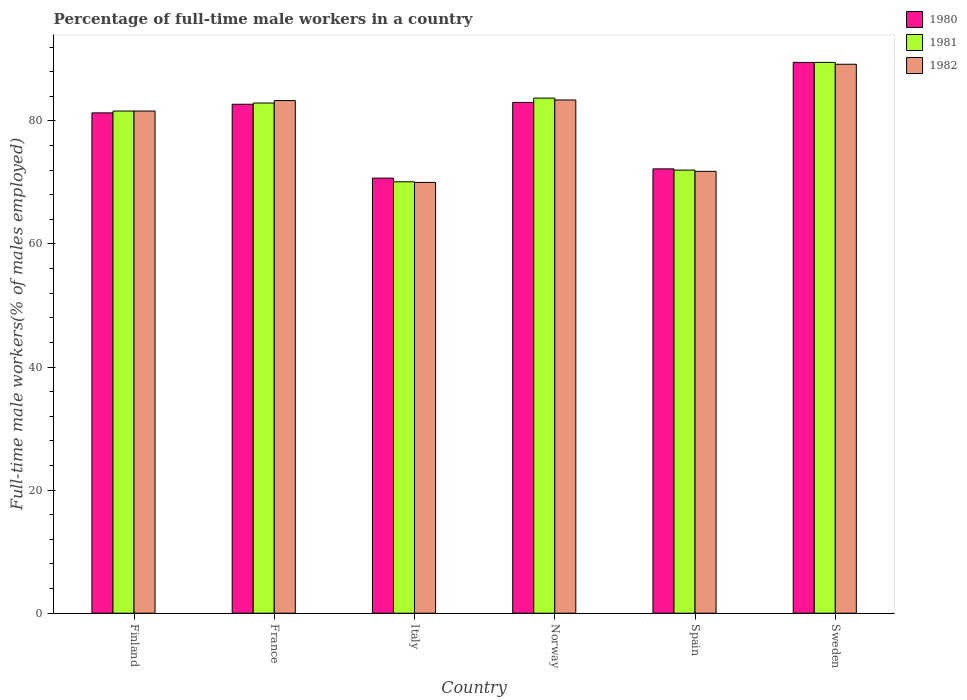How many different coloured bars are there?
Provide a short and direct response. 3. How many groups of bars are there?
Your answer should be compact. 6. Are the number of bars per tick equal to the number of legend labels?
Your response must be concise. Yes. How many bars are there on the 1st tick from the left?
Keep it short and to the point. 3. What is the label of the 3rd group of bars from the left?
Your response must be concise. Italy. What is the percentage of full-time male workers in 1982 in Sweden?
Give a very brief answer. 89.2. Across all countries, what is the maximum percentage of full-time male workers in 1980?
Provide a succinct answer. 89.5. Across all countries, what is the minimum percentage of full-time male workers in 1982?
Keep it short and to the point. 70. In which country was the percentage of full-time male workers in 1982 maximum?
Your response must be concise. Sweden. In which country was the percentage of full-time male workers in 1980 minimum?
Offer a terse response. Italy. What is the total percentage of full-time male workers in 1982 in the graph?
Your response must be concise. 479.3. What is the difference between the percentage of full-time male workers in 1982 in Norway and that in Sweden?
Offer a very short reply. -5.8. What is the difference between the percentage of full-time male workers in 1982 in Spain and the percentage of full-time male workers in 1981 in Norway?
Ensure brevity in your answer.  -11.9. What is the average percentage of full-time male workers in 1982 per country?
Ensure brevity in your answer.  79.88. What is the difference between the percentage of full-time male workers of/in 1981 and percentage of full-time male workers of/in 1982 in Sweden?
Your answer should be compact. 0.3. What is the ratio of the percentage of full-time male workers in 1981 in France to that in Italy?
Give a very brief answer. 1.18. What is the difference between the highest and the second highest percentage of full-time male workers in 1982?
Keep it short and to the point. 5.9. What is the difference between the highest and the lowest percentage of full-time male workers in 1980?
Provide a succinct answer. 18.8. In how many countries, is the percentage of full-time male workers in 1981 greater than the average percentage of full-time male workers in 1981 taken over all countries?
Provide a short and direct response. 4. Is the sum of the percentage of full-time male workers in 1980 in Italy and Spain greater than the maximum percentage of full-time male workers in 1982 across all countries?
Ensure brevity in your answer.  Yes. What does the 3rd bar from the left in France represents?
Give a very brief answer. 1982. What does the 3rd bar from the right in Italy represents?
Provide a succinct answer. 1980. Are all the bars in the graph horizontal?
Give a very brief answer. No. How many countries are there in the graph?
Your answer should be very brief. 6. What is the difference between two consecutive major ticks on the Y-axis?
Ensure brevity in your answer.  20. Where does the legend appear in the graph?
Provide a short and direct response. Top right. How many legend labels are there?
Provide a short and direct response. 3. How are the legend labels stacked?
Your response must be concise. Vertical. What is the title of the graph?
Your answer should be compact. Percentage of full-time male workers in a country. Does "1962" appear as one of the legend labels in the graph?
Offer a very short reply. No. What is the label or title of the Y-axis?
Give a very brief answer. Full-time male workers(% of males employed). What is the Full-time male workers(% of males employed) in 1980 in Finland?
Offer a terse response. 81.3. What is the Full-time male workers(% of males employed) of 1981 in Finland?
Offer a very short reply. 81.6. What is the Full-time male workers(% of males employed) of 1982 in Finland?
Ensure brevity in your answer.  81.6. What is the Full-time male workers(% of males employed) in 1980 in France?
Provide a succinct answer. 82.7. What is the Full-time male workers(% of males employed) of 1981 in France?
Ensure brevity in your answer.  82.9. What is the Full-time male workers(% of males employed) in 1982 in France?
Offer a terse response. 83.3. What is the Full-time male workers(% of males employed) in 1980 in Italy?
Make the answer very short. 70.7. What is the Full-time male workers(% of males employed) in 1981 in Italy?
Ensure brevity in your answer.  70.1. What is the Full-time male workers(% of males employed) of 1982 in Italy?
Your answer should be compact. 70. What is the Full-time male workers(% of males employed) in 1981 in Norway?
Your answer should be compact. 83.7. What is the Full-time male workers(% of males employed) of 1982 in Norway?
Your answer should be very brief. 83.4. What is the Full-time male workers(% of males employed) in 1980 in Spain?
Your answer should be compact. 72.2. What is the Full-time male workers(% of males employed) in 1981 in Spain?
Keep it short and to the point. 72. What is the Full-time male workers(% of males employed) in 1982 in Spain?
Offer a very short reply. 71.8. What is the Full-time male workers(% of males employed) of 1980 in Sweden?
Offer a very short reply. 89.5. What is the Full-time male workers(% of males employed) of 1981 in Sweden?
Keep it short and to the point. 89.5. What is the Full-time male workers(% of males employed) in 1982 in Sweden?
Provide a succinct answer. 89.2. Across all countries, what is the maximum Full-time male workers(% of males employed) of 1980?
Provide a short and direct response. 89.5. Across all countries, what is the maximum Full-time male workers(% of males employed) of 1981?
Give a very brief answer. 89.5. Across all countries, what is the maximum Full-time male workers(% of males employed) in 1982?
Keep it short and to the point. 89.2. Across all countries, what is the minimum Full-time male workers(% of males employed) in 1980?
Ensure brevity in your answer.  70.7. Across all countries, what is the minimum Full-time male workers(% of males employed) of 1981?
Give a very brief answer. 70.1. What is the total Full-time male workers(% of males employed) in 1980 in the graph?
Your answer should be very brief. 479.4. What is the total Full-time male workers(% of males employed) of 1981 in the graph?
Provide a short and direct response. 479.8. What is the total Full-time male workers(% of males employed) of 1982 in the graph?
Provide a succinct answer. 479.3. What is the difference between the Full-time male workers(% of males employed) of 1981 in Finland and that in Italy?
Provide a short and direct response. 11.5. What is the difference between the Full-time male workers(% of males employed) in 1982 in Finland and that in Italy?
Provide a succinct answer. 11.6. What is the difference between the Full-time male workers(% of males employed) of 1980 in Finland and that in Norway?
Give a very brief answer. -1.7. What is the difference between the Full-time male workers(% of males employed) in 1982 in Finland and that in Norway?
Provide a succinct answer. -1.8. What is the difference between the Full-time male workers(% of males employed) in 1980 in Finland and that in Spain?
Offer a terse response. 9.1. What is the difference between the Full-time male workers(% of males employed) of 1982 in Finland and that in Spain?
Make the answer very short. 9.8. What is the difference between the Full-time male workers(% of males employed) of 1981 in Finland and that in Sweden?
Your answer should be very brief. -7.9. What is the difference between the Full-time male workers(% of males employed) of 1980 in France and that in Italy?
Give a very brief answer. 12. What is the difference between the Full-time male workers(% of males employed) in 1981 in France and that in Italy?
Keep it short and to the point. 12.8. What is the difference between the Full-time male workers(% of males employed) in 1982 in France and that in Italy?
Make the answer very short. 13.3. What is the difference between the Full-time male workers(% of males employed) in 1980 in France and that in Norway?
Offer a very short reply. -0.3. What is the difference between the Full-time male workers(% of males employed) of 1980 in France and that in Spain?
Your response must be concise. 10.5. What is the difference between the Full-time male workers(% of males employed) of 1980 in France and that in Sweden?
Provide a succinct answer. -6.8. What is the difference between the Full-time male workers(% of males employed) in 1981 in France and that in Sweden?
Your answer should be very brief. -6.6. What is the difference between the Full-time male workers(% of males employed) in 1980 in Italy and that in Spain?
Your answer should be compact. -1.5. What is the difference between the Full-time male workers(% of males employed) of 1982 in Italy and that in Spain?
Ensure brevity in your answer.  -1.8. What is the difference between the Full-time male workers(% of males employed) in 1980 in Italy and that in Sweden?
Make the answer very short. -18.8. What is the difference between the Full-time male workers(% of males employed) in 1981 in Italy and that in Sweden?
Ensure brevity in your answer.  -19.4. What is the difference between the Full-time male workers(% of males employed) of 1982 in Italy and that in Sweden?
Your response must be concise. -19.2. What is the difference between the Full-time male workers(% of males employed) in 1980 in Norway and that in Sweden?
Your answer should be very brief. -6.5. What is the difference between the Full-time male workers(% of males employed) in 1981 in Norway and that in Sweden?
Offer a very short reply. -5.8. What is the difference between the Full-time male workers(% of males employed) of 1982 in Norway and that in Sweden?
Make the answer very short. -5.8. What is the difference between the Full-time male workers(% of males employed) of 1980 in Spain and that in Sweden?
Give a very brief answer. -17.3. What is the difference between the Full-time male workers(% of males employed) of 1981 in Spain and that in Sweden?
Offer a very short reply. -17.5. What is the difference between the Full-time male workers(% of males employed) in 1982 in Spain and that in Sweden?
Keep it short and to the point. -17.4. What is the difference between the Full-time male workers(% of males employed) of 1980 in Finland and the Full-time male workers(% of males employed) of 1981 in France?
Give a very brief answer. -1.6. What is the difference between the Full-time male workers(% of males employed) in 1980 in Finland and the Full-time male workers(% of males employed) in 1982 in France?
Offer a very short reply. -2. What is the difference between the Full-time male workers(% of males employed) of 1981 in Finland and the Full-time male workers(% of males employed) of 1982 in France?
Provide a succinct answer. -1.7. What is the difference between the Full-time male workers(% of males employed) in 1980 in Finland and the Full-time male workers(% of males employed) in 1982 in Italy?
Give a very brief answer. 11.3. What is the difference between the Full-time male workers(% of males employed) of 1981 in Finland and the Full-time male workers(% of males employed) of 1982 in Norway?
Give a very brief answer. -1.8. What is the difference between the Full-time male workers(% of males employed) in 1980 in Finland and the Full-time male workers(% of males employed) in 1981 in Spain?
Provide a succinct answer. 9.3. What is the difference between the Full-time male workers(% of males employed) in 1980 in Finland and the Full-time male workers(% of males employed) in 1982 in Spain?
Ensure brevity in your answer.  9.5. What is the difference between the Full-time male workers(% of males employed) in 1980 in Finland and the Full-time male workers(% of males employed) in 1981 in Sweden?
Ensure brevity in your answer.  -8.2. What is the difference between the Full-time male workers(% of males employed) in 1981 in Finland and the Full-time male workers(% of males employed) in 1982 in Sweden?
Provide a succinct answer. -7.6. What is the difference between the Full-time male workers(% of males employed) of 1980 in France and the Full-time male workers(% of males employed) of 1981 in Italy?
Provide a succinct answer. 12.6. What is the difference between the Full-time male workers(% of males employed) of 1980 in France and the Full-time male workers(% of males employed) of 1982 in Italy?
Offer a terse response. 12.7. What is the difference between the Full-time male workers(% of males employed) in 1981 in France and the Full-time male workers(% of males employed) in 1982 in Spain?
Keep it short and to the point. 11.1. What is the difference between the Full-time male workers(% of males employed) of 1980 in Italy and the Full-time male workers(% of males employed) of 1981 in Norway?
Keep it short and to the point. -13. What is the difference between the Full-time male workers(% of males employed) of 1980 in Italy and the Full-time male workers(% of males employed) of 1982 in Norway?
Provide a short and direct response. -12.7. What is the difference between the Full-time male workers(% of males employed) in 1980 in Italy and the Full-time male workers(% of males employed) in 1981 in Spain?
Provide a short and direct response. -1.3. What is the difference between the Full-time male workers(% of males employed) in 1980 in Italy and the Full-time male workers(% of males employed) in 1982 in Spain?
Give a very brief answer. -1.1. What is the difference between the Full-time male workers(% of males employed) in 1981 in Italy and the Full-time male workers(% of males employed) in 1982 in Spain?
Offer a terse response. -1.7. What is the difference between the Full-time male workers(% of males employed) in 1980 in Italy and the Full-time male workers(% of males employed) in 1981 in Sweden?
Give a very brief answer. -18.8. What is the difference between the Full-time male workers(% of males employed) of 1980 in Italy and the Full-time male workers(% of males employed) of 1982 in Sweden?
Ensure brevity in your answer.  -18.5. What is the difference between the Full-time male workers(% of males employed) of 1981 in Italy and the Full-time male workers(% of males employed) of 1982 in Sweden?
Ensure brevity in your answer.  -19.1. What is the difference between the Full-time male workers(% of males employed) of 1981 in Norway and the Full-time male workers(% of males employed) of 1982 in Spain?
Give a very brief answer. 11.9. What is the difference between the Full-time male workers(% of males employed) in 1980 in Norway and the Full-time male workers(% of males employed) in 1981 in Sweden?
Your response must be concise. -6.5. What is the difference between the Full-time male workers(% of males employed) of 1980 in Norway and the Full-time male workers(% of males employed) of 1982 in Sweden?
Make the answer very short. -6.2. What is the difference between the Full-time male workers(% of males employed) in 1981 in Norway and the Full-time male workers(% of males employed) in 1982 in Sweden?
Your answer should be very brief. -5.5. What is the difference between the Full-time male workers(% of males employed) in 1980 in Spain and the Full-time male workers(% of males employed) in 1981 in Sweden?
Provide a succinct answer. -17.3. What is the difference between the Full-time male workers(% of males employed) of 1981 in Spain and the Full-time male workers(% of males employed) of 1982 in Sweden?
Your answer should be compact. -17.2. What is the average Full-time male workers(% of males employed) of 1980 per country?
Offer a very short reply. 79.9. What is the average Full-time male workers(% of males employed) in 1981 per country?
Provide a succinct answer. 79.97. What is the average Full-time male workers(% of males employed) in 1982 per country?
Your answer should be compact. 79.88. What is the difference between the Full-time male workers(% of males employed) of 1980 and Full-time male workers(% of males employed) of 1981 in Finland?
Offer a terse response. -0.3. What is the difference between the Full-time male workers(% of males employed) of 1980 and Full-time male workers(% of males employed) of 1982 in Finland?
Your response must be concise. -0.3. What is the difference between the Full-time male workers(% of males employed) of 1980 and Full-time male workers(% of males employed) of 1981 in Italy?
Keep it short and to the point. 0.6. What is the difference between the Full-time male workers(% of males employed) in 1980 and Full-time male workers(% of males employed) in 1982 in Italy?
Provide a succinct answer. 0.7. What is the difference between the Full-time male workers(% of males employed) of 1980 and Full-time male workers(% of males employed) of 1982 in Spain?
Your response must be concise. 0.4. What is the difference between the Full-time male workers(% of males employed) in 1980 and Full-time male workers(% of males employed) in 1982 in Sweden?
Your answer should be very brief. 0.3. What is the ratio of the Full-time male workers(% of males employed) in 1980 in Finland to that in France?
Your answer should be compact. 0.98. What is the ratio of the Full-time male workers(% of males employed) of 1981 in Finland to that in France?
Offer a terse response. 0.98. What is the ratio of the Full-time male workers(% of males employed) of 1982 in Finland to that in France?
Your answer should be compact. 0.98. What is the ratio of the Full-time male workers(% of males employed) of 1980 in Finland to that in Italy?
Provide a short and direct response. 1.15. What is the ratio of the Full-time male workers(% of males employed) in 1981 in Finland to that in Italy?
Ensure brevity in your answer.  1.16. What is the ratio of the Full-time male workers(% of males employed) in 1982 in Finland to that in Italy?
Your response must be concise. 1.17. What is the ratio of the Full-time male workers(% of males employed) in 1980 in Finland to that in Norway?
Provide a succinct answer. 0.98. What is the ratio of the Full-time male workers(% of males employed) of 1981 in Finland to that in Norway?
Ensure brevity in your answer.  0.97. What is the ratio of the Full-time male workers(% of males employed) of 1982 in Finland to that in Norway?
Your answer should be very brief. 0.98. What is the ratio of the Full-time male workers(% of males employed) in 1980 in Finland to that in Spain?
Keep it short and to the point. 1.13. What is the ratio of the Full-time male workers(% of males employed) of 1981 in Finland to that in Spain?
Ensure brevity in your answer.  1.13. What is the ratio of the Full-time male workers(% of males employed) of 1982 in Finland to that in Spain?
Give a very brief answer. 1.14. What is the ratio of the Full-time male workers(% of males employed) of 1980 in Finland to that in Sweden?
Ensure brevity in your answer.  0.91. What is the ratio of the Full-time male workers(% of males employed) of 1981 in Finland to that in Sweden?
Make the answer very short. 0.91. What is the ratio of the Full-time male workers(% of males employed) of 1982 in Finland to that in Sweden?
Your answer should be compact. 0.91. What is the ratio of the Full-time male workers(% of males employed) in 1980 in France to that in Italy?
Your answer should be compact. 1.17. What is the ratio of the Full-time male workers(% of males employed) of 1981 in France to that in Italy?
Offer a terse response. 1.18. What is the ratio of the Full-time male workers(% of males employed) in 1982 in France to that in Italy?
Offer a terse response. 1.19. What is the ratio of the Full-time male workers(% of males employed) in 1980 in France to that in Spain?
Your response must be concise. 1.15. What is the ratio of the Full-time male workers(% of males employed) in 1981 in France to that in Spain?
Give a very brief answer. 1.15. What is the ratio of the Full-time male workers(% of males employed) of 1982 in France to that in Spain?
Ensure brevity in your answer.  1.16. What is the ratio of the Full-time male workers(% of males employed) of 1980 in France to that in Sweden?
Make the answer very short. 0.92. What is the ratio of the Full-time male workers(% of males employed) of 1981 in France to that in Sweden?
Offer a very short reply. 0.93. What is the ratio of the Full-time male workers(% of males employed) of 1982 in France to that in Sweden?
Offer a terse response. 0.93. What is the ratio of the Full-time male workers(% of males employed) in 1980 in Italy to that in Norway?
Your answer should be compact. 0.85. What is the ratio of the Full-time male workers(% of males employed) of 1981 in Italy to that in Norway?
Offer a very short reply. 0.84. What is the ratio of the Full-time male workers(% of males employed) in 1982 in Italy to that in Norway?
Make the answer very short. 0.84. What is the ratio of the Full-time male workers(% of males employed) of 1980 in Italy to that in Spain?
Your response must be concise. 0.98. What is the ratio of the Full-time male workers(% of males employed) of 1981 in Italy to that in Spain?
Give a very brief answer. 0.97. What is the ratio of the Full-time male workers(% of males employed) in 1982 in Italy to that in Spain?
Give a very brief answer. 0.97. What is the ratio of the Full-time male workers(% of males employed) of 1980 in Italy to that in Sweden?
Give a very brief answer. 0.79. What is the ratio of the Full-time male workers(% of males employed) in 1981 in Italy to that in Sweden?
Provide a succinct answer. 0.78. What is the ratio of the Full-time male workers(% of males employed) of 1982 in Italy to that in Sweden?
Your response must be concise. 0.78. What is the ratio of the Full-time male workers(% of males employed) of 1980 in Norway to that in Spain?
Offer a terse response. 1.15. What is the ratio of the Full-time male workers(% of males employed) in 1981 in Norway to that in Spain?
Make the answer very short. 1.16. What is the ratio of the Full-time male workers(% of males employed) in 1982 in Norway to that in Spain?
Make the answer very short. 1.16. What is the ratio of the Full-time male workers(% of males employed) in 1980 in Norway to that in Sweden?
Provide a succinct answer. 0.93. What is the ratio of the Full-time male workers(% of males employed) in 1981 in Norway to that in Sweden?
Offer a very short reply. 0.94. What is the ratio of the Full-time male workers(% of males employed) of 1982 in Norway to that in Sweden?
Provide a succinct answer. 0.94. What is the ratio of the Full-time male workers(% of males employed) in 1980 in Spain to that in Sweden?
Provide a short and direct response. 0.81. What is the ratio of the Full-time male workers(% of males employed) in 1981 in Spain to that in Sweden?
Provide a short and direct response. 0.8. What is the ratio of the Full-time male workers(% of males employed) in 1982 in Spain to that in Sweden?
Provide a succinct answer. 0.8. What is the difference between the highest and the second highest Full-time male workers(% of males employed) of 1980?
Offer a very short reply. 6.5. What is the difference between the highest and the second highest Full-time male workers(% of males employed) in 1981?
Offer a very short reply. 5.8. What is the difference between the highest and the second highest Full-time male workers(% of males employed) in 1982?
Offer a very short reply. 5.8. 